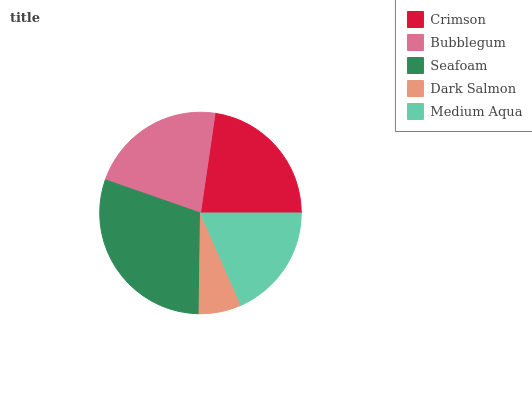Is Dark Salmon the minimum?
Answer yes or no. Yes. Is Seafoam the maximum?
Answer yes or no. Yes. Is Bubblegum the minimum?
Answer yes or no. No. Is Bubblegum the maximum?
Answer yes or no. No. Is Crimson greater than Bubblegum?
Answer yes or no. Yes. Is Bubblegum less than Crimson?
Answer yes or no. Yes. Is Bubblegum greater than Crimson?
Answer yes or no. No. Is Crimson less than Bubblegum?
Answer yes or no. No. Is Bubblegum the high median?
Answer yes or no. Yes. Is Bubblegum the low median?
Answer yes or no. Yes. Is Seafoam the high median?
Answer yes or no. No. Is Crimson the low median?
Answer yes or no. No. 